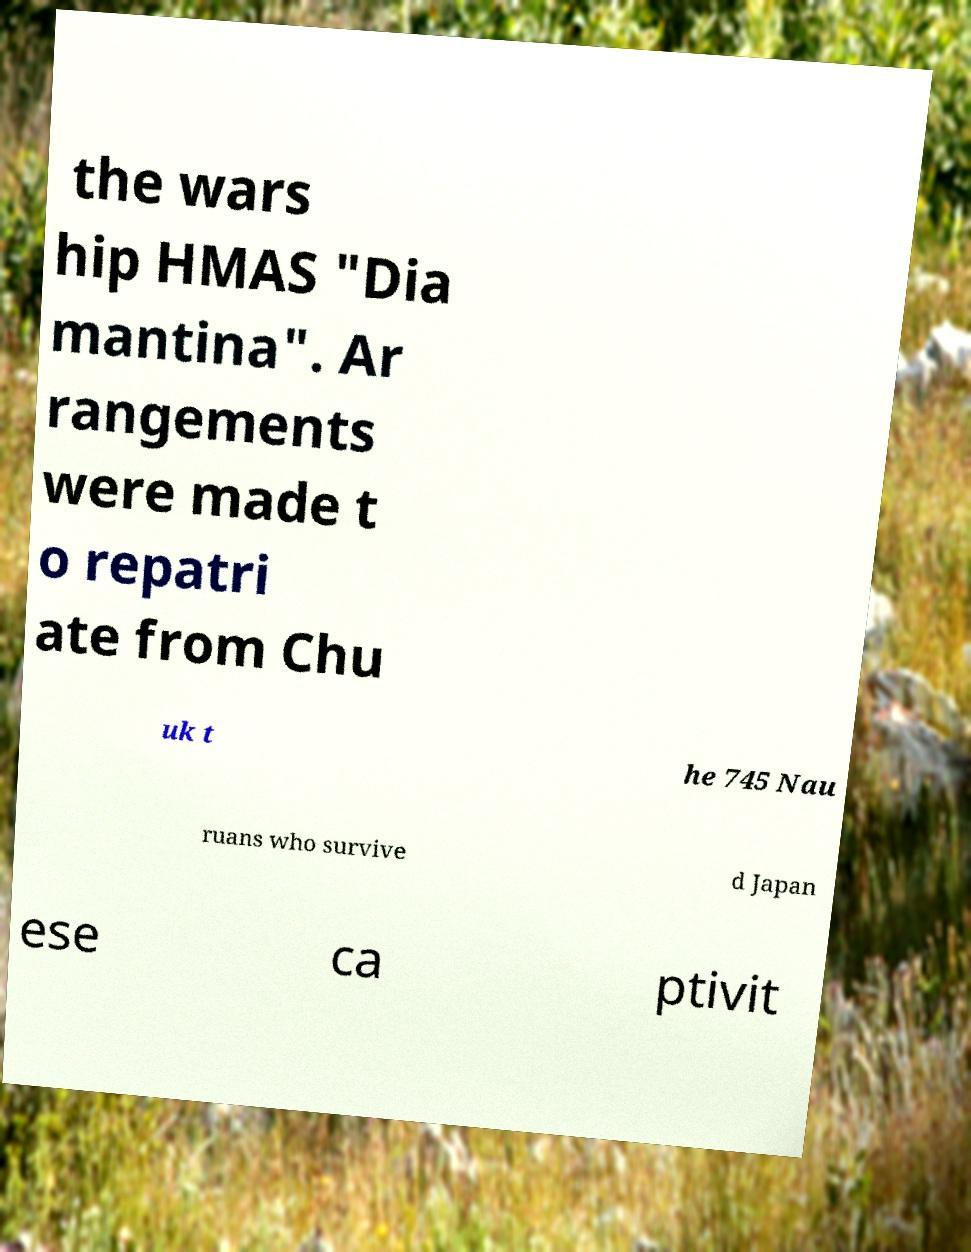There's text embedded in this image that I need extracted. Can you transcribe it verbatim? the wars hip HMAS "Dia mantina". Ar rangements were made t o repatri ate from Chu uk t he 745 Nau ruans who survive d Japan ese ca ptivit 